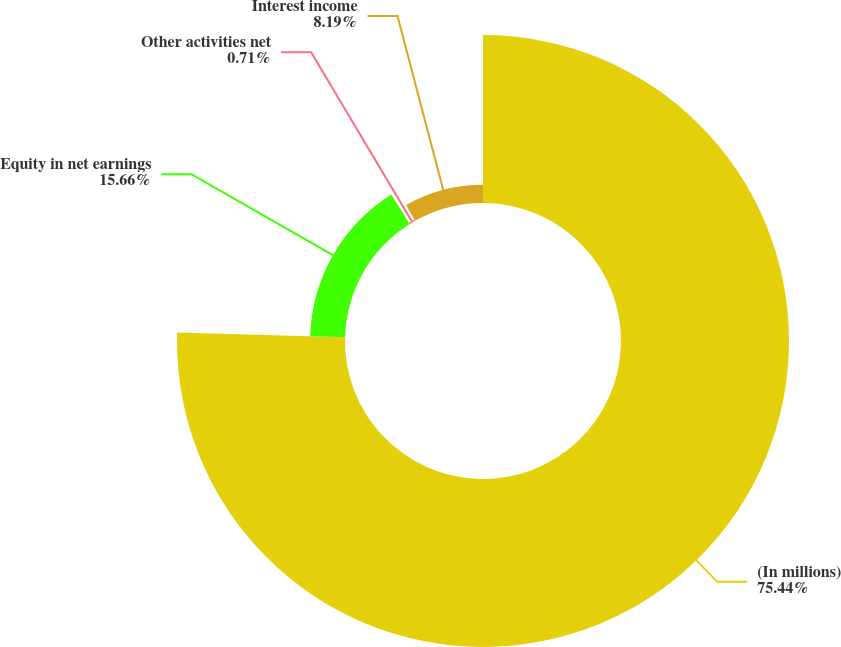<chart> <loc_0><loc_0><loc_500><loc_500><pie_chart><fcel>(In millions)<fcel>Equity in net earnings<fcel>Other activities net<fcel>Interest income<nl><fcel>75.44%<fcel>15.66%<fcel>0.71%<fcel>8.19%<nl></chart> 